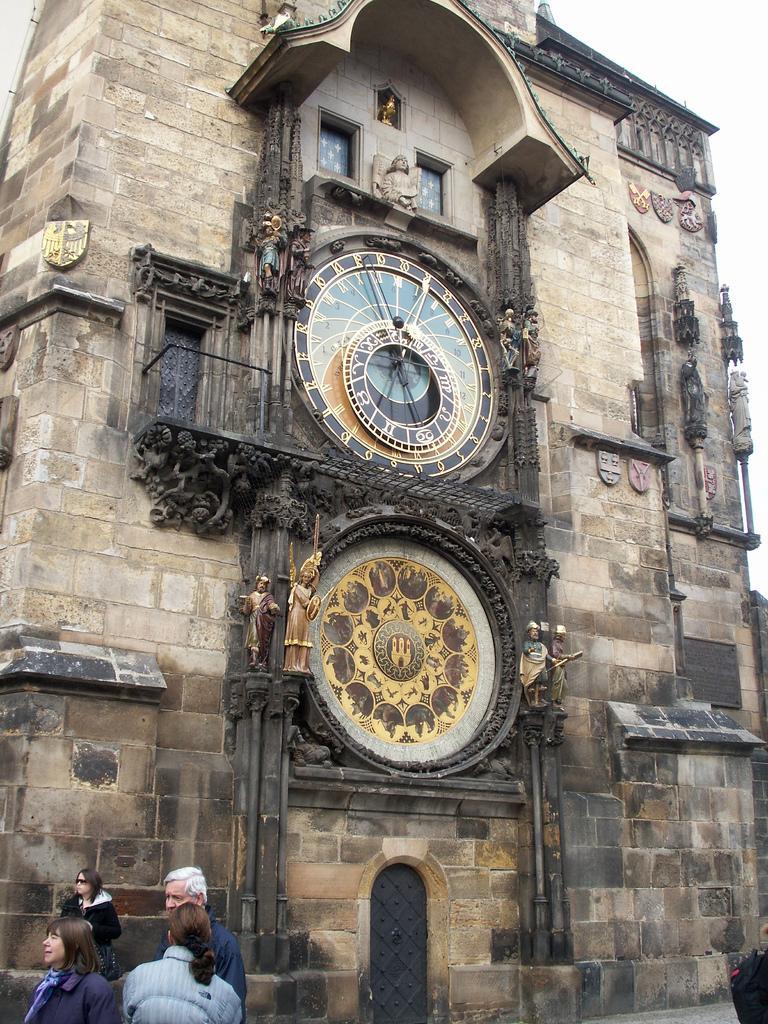How would you summarize this image in a sentence or two? In this image I can see few people standing on the left. There is a building which has a clock and sculptures. 